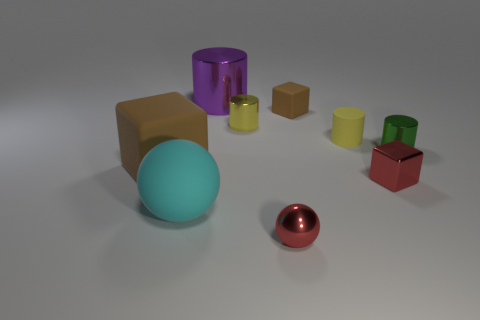Is the shiny block the same color as the small shiny sphere?
Offer a terse response. Yes. What shape is the small object that is the same color as the shiny cube?
Offer a very short reply. Sphere. What number of cylinders are small brown matte things or big shiny things?
Keep it short and to the point. 1. How many large cyan balls have the same material as the big purple cylinder?
Your response must be concise. 0. Are the brown object that is in front of the green cylinder and the tiny red object that is in front of the large cyan sphere made of the same material?
Offer a very short reply. No. There is a large object behind the brown rubber object in front of the small green cylinder; how many yellow matte objects are on the right side of it?
Provide a short and direct response. 1. There is a small metal cylinder that is left of the red ball; is it the same color as the rubber cylinder in front of the yellow metallic object?
Make the answer very short. Yes. Is there any other thing that has the same color as the large matte cube?
Your response must be concise. Yes. There is a tiny cylinder left of the tiny thing that is in front of the tiny metal cube; what is its color?
Your response must be concise. Yellow. Are any large cyan spheres visible?
Provide a short and direct response. Yes. 